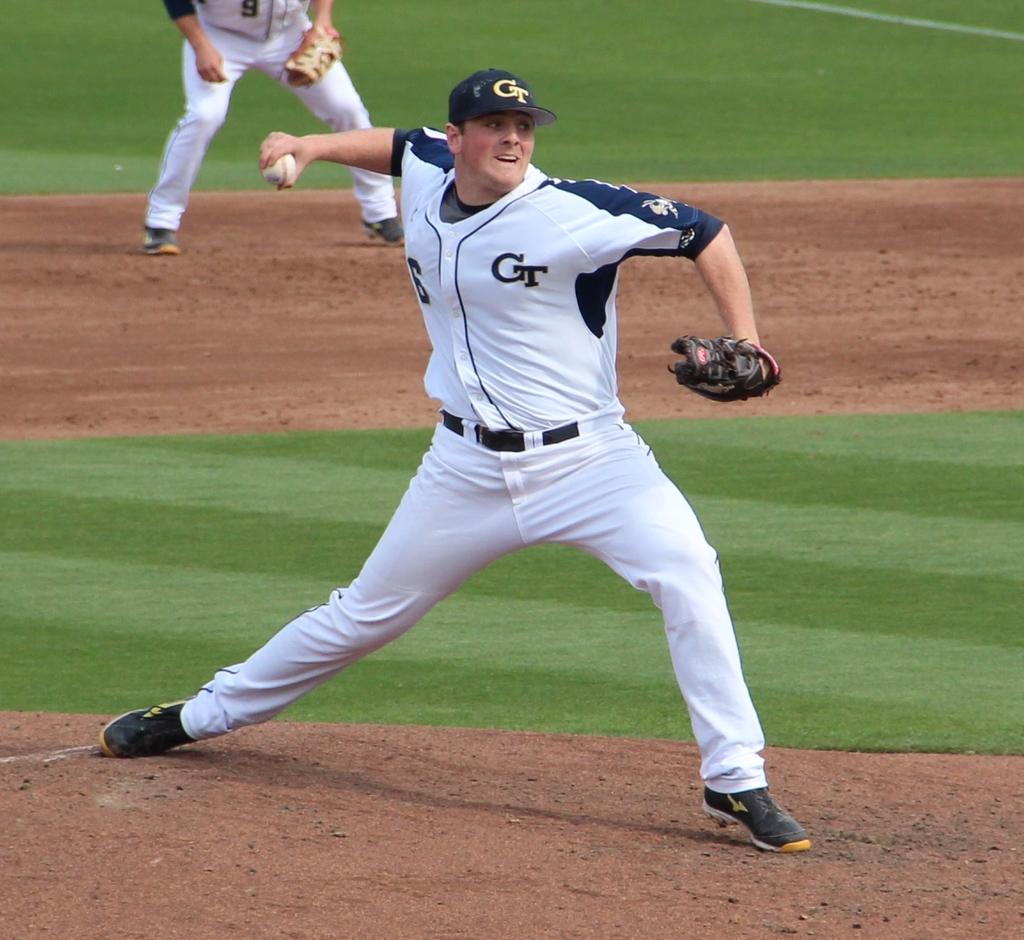Is the pitcher for gt playing?
Give a very brief answer. Yes. What number is on the jersey in the background?
Your answer should be compact. 9. 